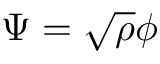<formula> <loc_0><loc_0><loc_500><loc_500>\Psi = \sqrt { \rho } \phi</formula> 